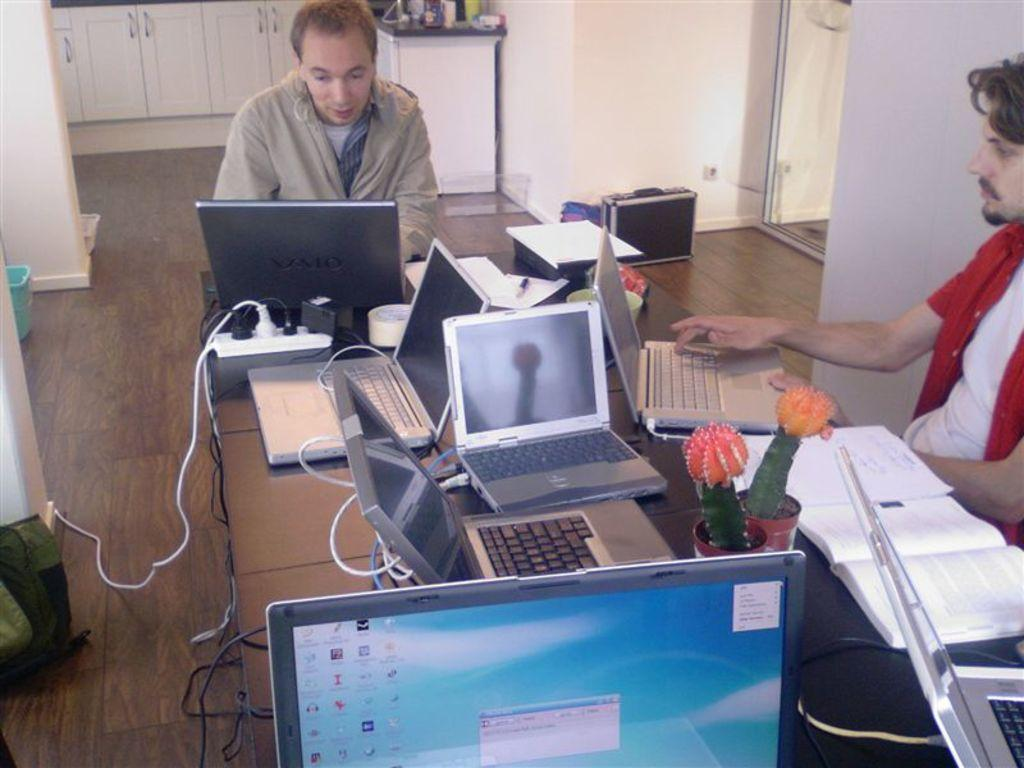<image>
Give a short and clear explanation of the subsequent image. Two men sitting at a table with a computer screen on which reads "View" very small in the top right corner. 